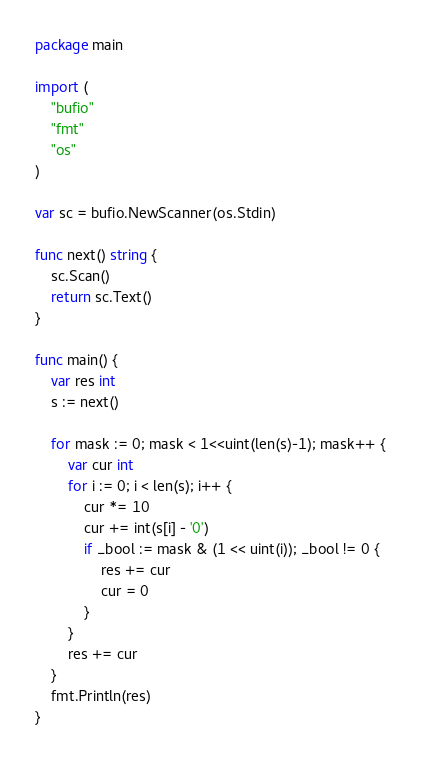<code> <loc_0><loc_0><loc_500><loc_500><_Go_>package main

import (
	"bufio"
	"fmt"
	"os"
)

var sc = bufio.NewScanner(os.Stdin)

func next() string {
	sc.Scan()
	return sc.Text()
}

func main() {
	var res int
	s := next()

	for mask := 0; mask < 1<<uint(len(s)-1); mask++ {
		var cur int
		for i := 0; i < len(s); i++ {
			cur *= 10
			cur += int(s[i] - '0')
			if _bool := mask & (1 << uint(i)); _bool != 0 {
				res += cur
				cur = 0
			}
		}
		res += cur
	}
	fmt.Println(res)
}</code> 